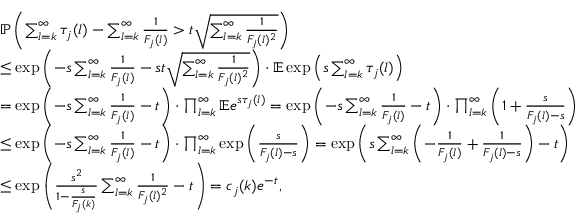Convert formula to latex. <formula><loc_0><loc_0><loc_500><loc_500>\begin{array} { r l } & { \mathbb { P } \left ( \sum _ { l = k } ^ { \infty } \tau _ { j } ( l ) - \sum _ { l = k } ^ { \infty } \frac { 1 } { F _ { j } ( l ) } > t \sqrt { \sum _ { l = k } ^ { \infty } \frac { 1 } { F _ { j } ( l ) ^ { 2 } } } \right ) } \\ & { \leq \exp \left ( - s \sum _ { l = k } ^ { \infty } \frac { 1 } { F _ { j } ( l ) } - s t \sqrt { \sum _ { l = k } ^ { \infty } \frac { 1 } { F _ { j } ( l ) ^ { 2 } } } \right ) \cdot \mathbb { E } \exp \left ( s \sum _ { l = k } ^ { \infty } \tau _ { j } ( l ) \right ) } \\ & { = \exp \left ( - s \sum _ { l = k } ^ { \infty } \frac { 1 } { F _ { j } ( l ) } - t \right ) \cdot \prod _ { l = k } ^ { \infty } \mathbb { E } e ^ { s \tau _ { j } ( l ) } = \exp \left ( - s \sum _ { l = k } ^ { \infty } \frac { 1 } { F _ { j } ( l ) } - t \right ) \cdot \prod _ { l = k } ^ { \infty } \left ( 1 + \frac { s } { F _ { j } ( l ) - s } \right ) } \\ & { \leq \exp \left ( - s \sum _ { l = k } ^ { \infty } \frac { 1 } { F _ { j } ( l ) } - t \right ) \cdot \prod _ { l = k } ^ { \infty } \exp \left ( \frac { s } { F _ { j } ( l ) - s } \right ) = \exp \left ( s \sum _ { l = k } ^ { \infty } \left ( - \frac { 1 } { F _ { j } ( l ) } + \frac { 1 } { F _ { j } ( l ) - s } \right ) - t \right ) } \\ & { \leq \exp \left ( \frac { s ^ { 2 } } { 1 - \frac { s } { F _ { j } ( k ) } } \sum _ { l = k } ^ { \infty } \frac { 1 } { F _ { j } ( l ) ^ { 2 } } - t \right ) = c _ { j } ( k ) e ^ { - t } , } \end{array}</formula> 